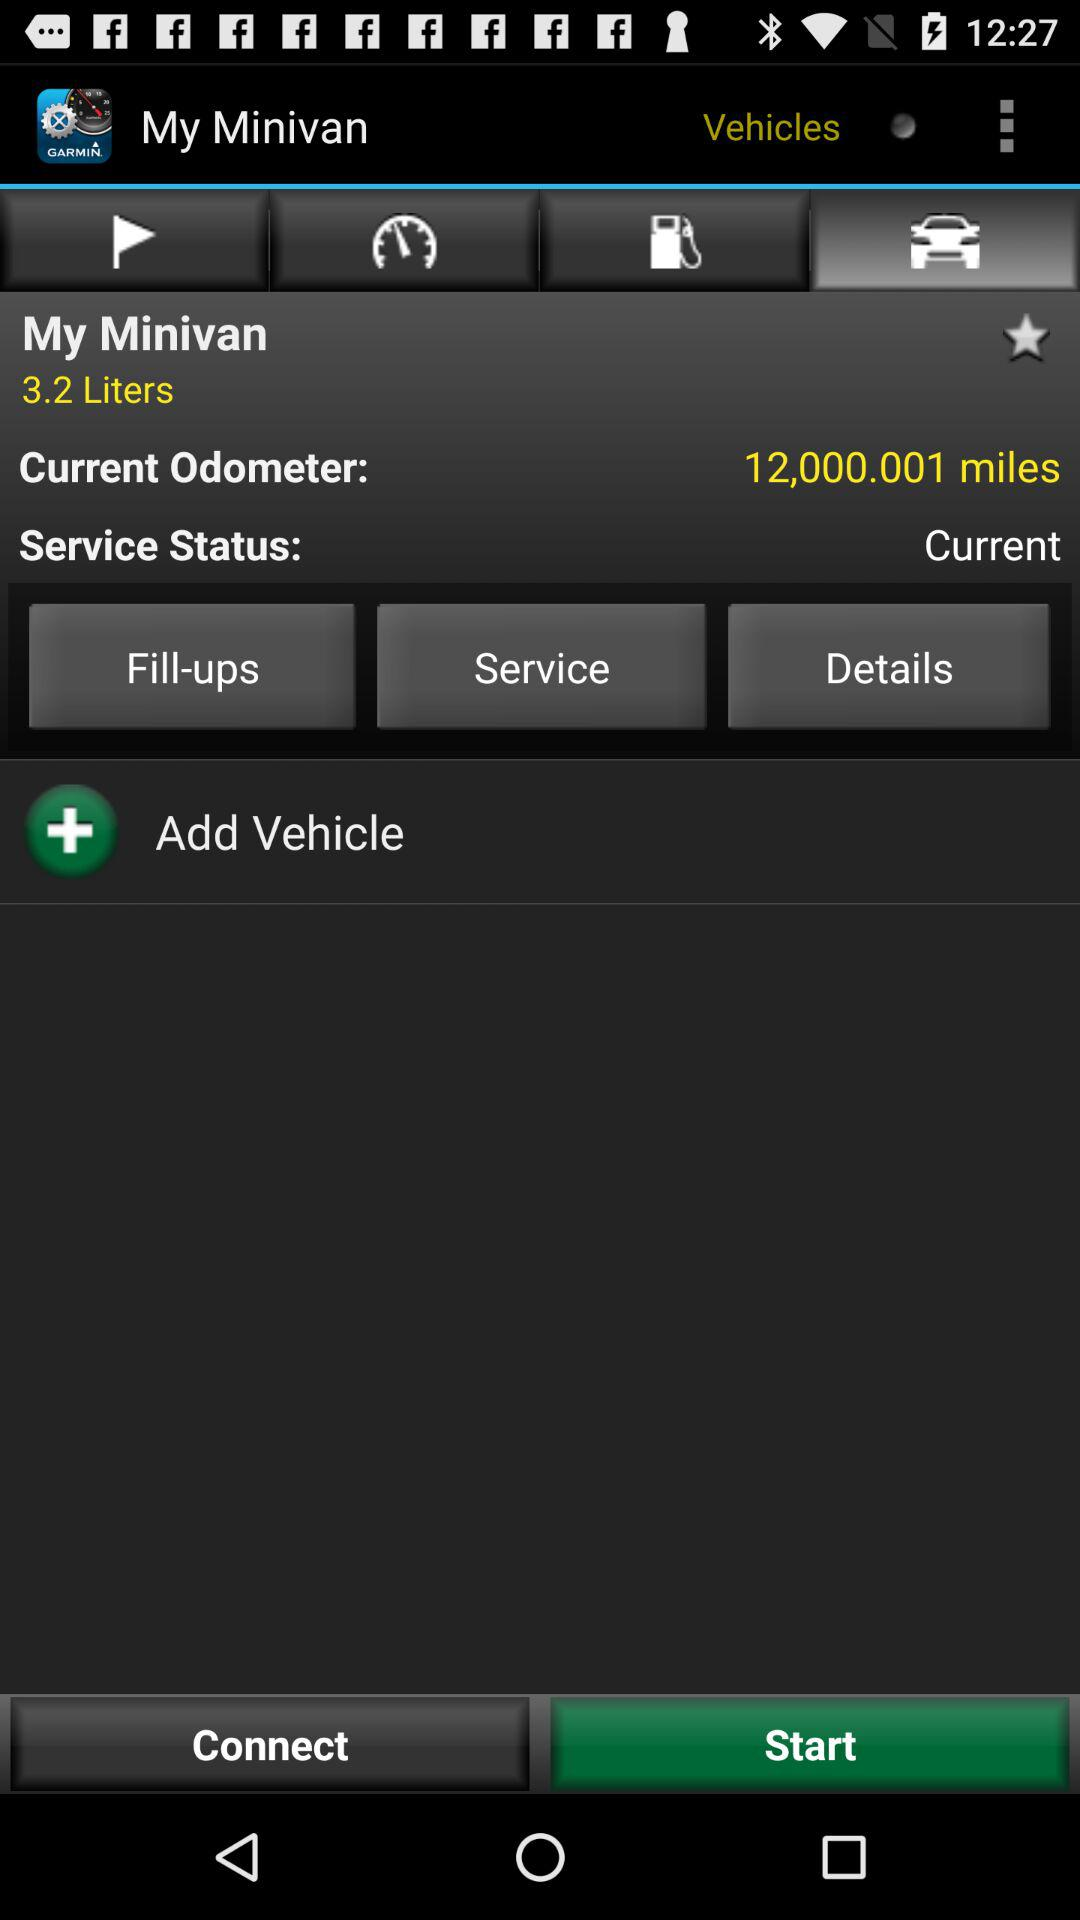What is the current status of the vehicle?
Answer the question using a single word or phrase. Current 